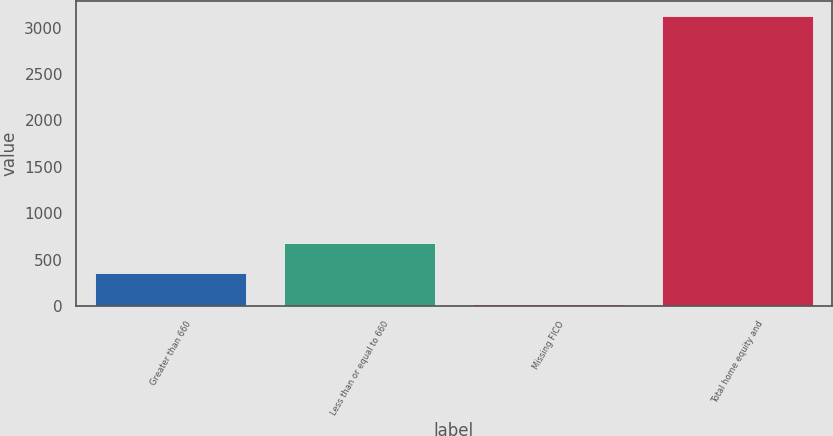Convert chart. <chart><loc_0><loc_0><loc_500><loc_500><bar_chart><fcel>Greater than 660<fcel>Less than or equal to 660<fcel>Missing FICO<fcel>Total home equity and<nl><fcel>361<fcel>681<fcel>22<fcel>3128<nl></chart> 